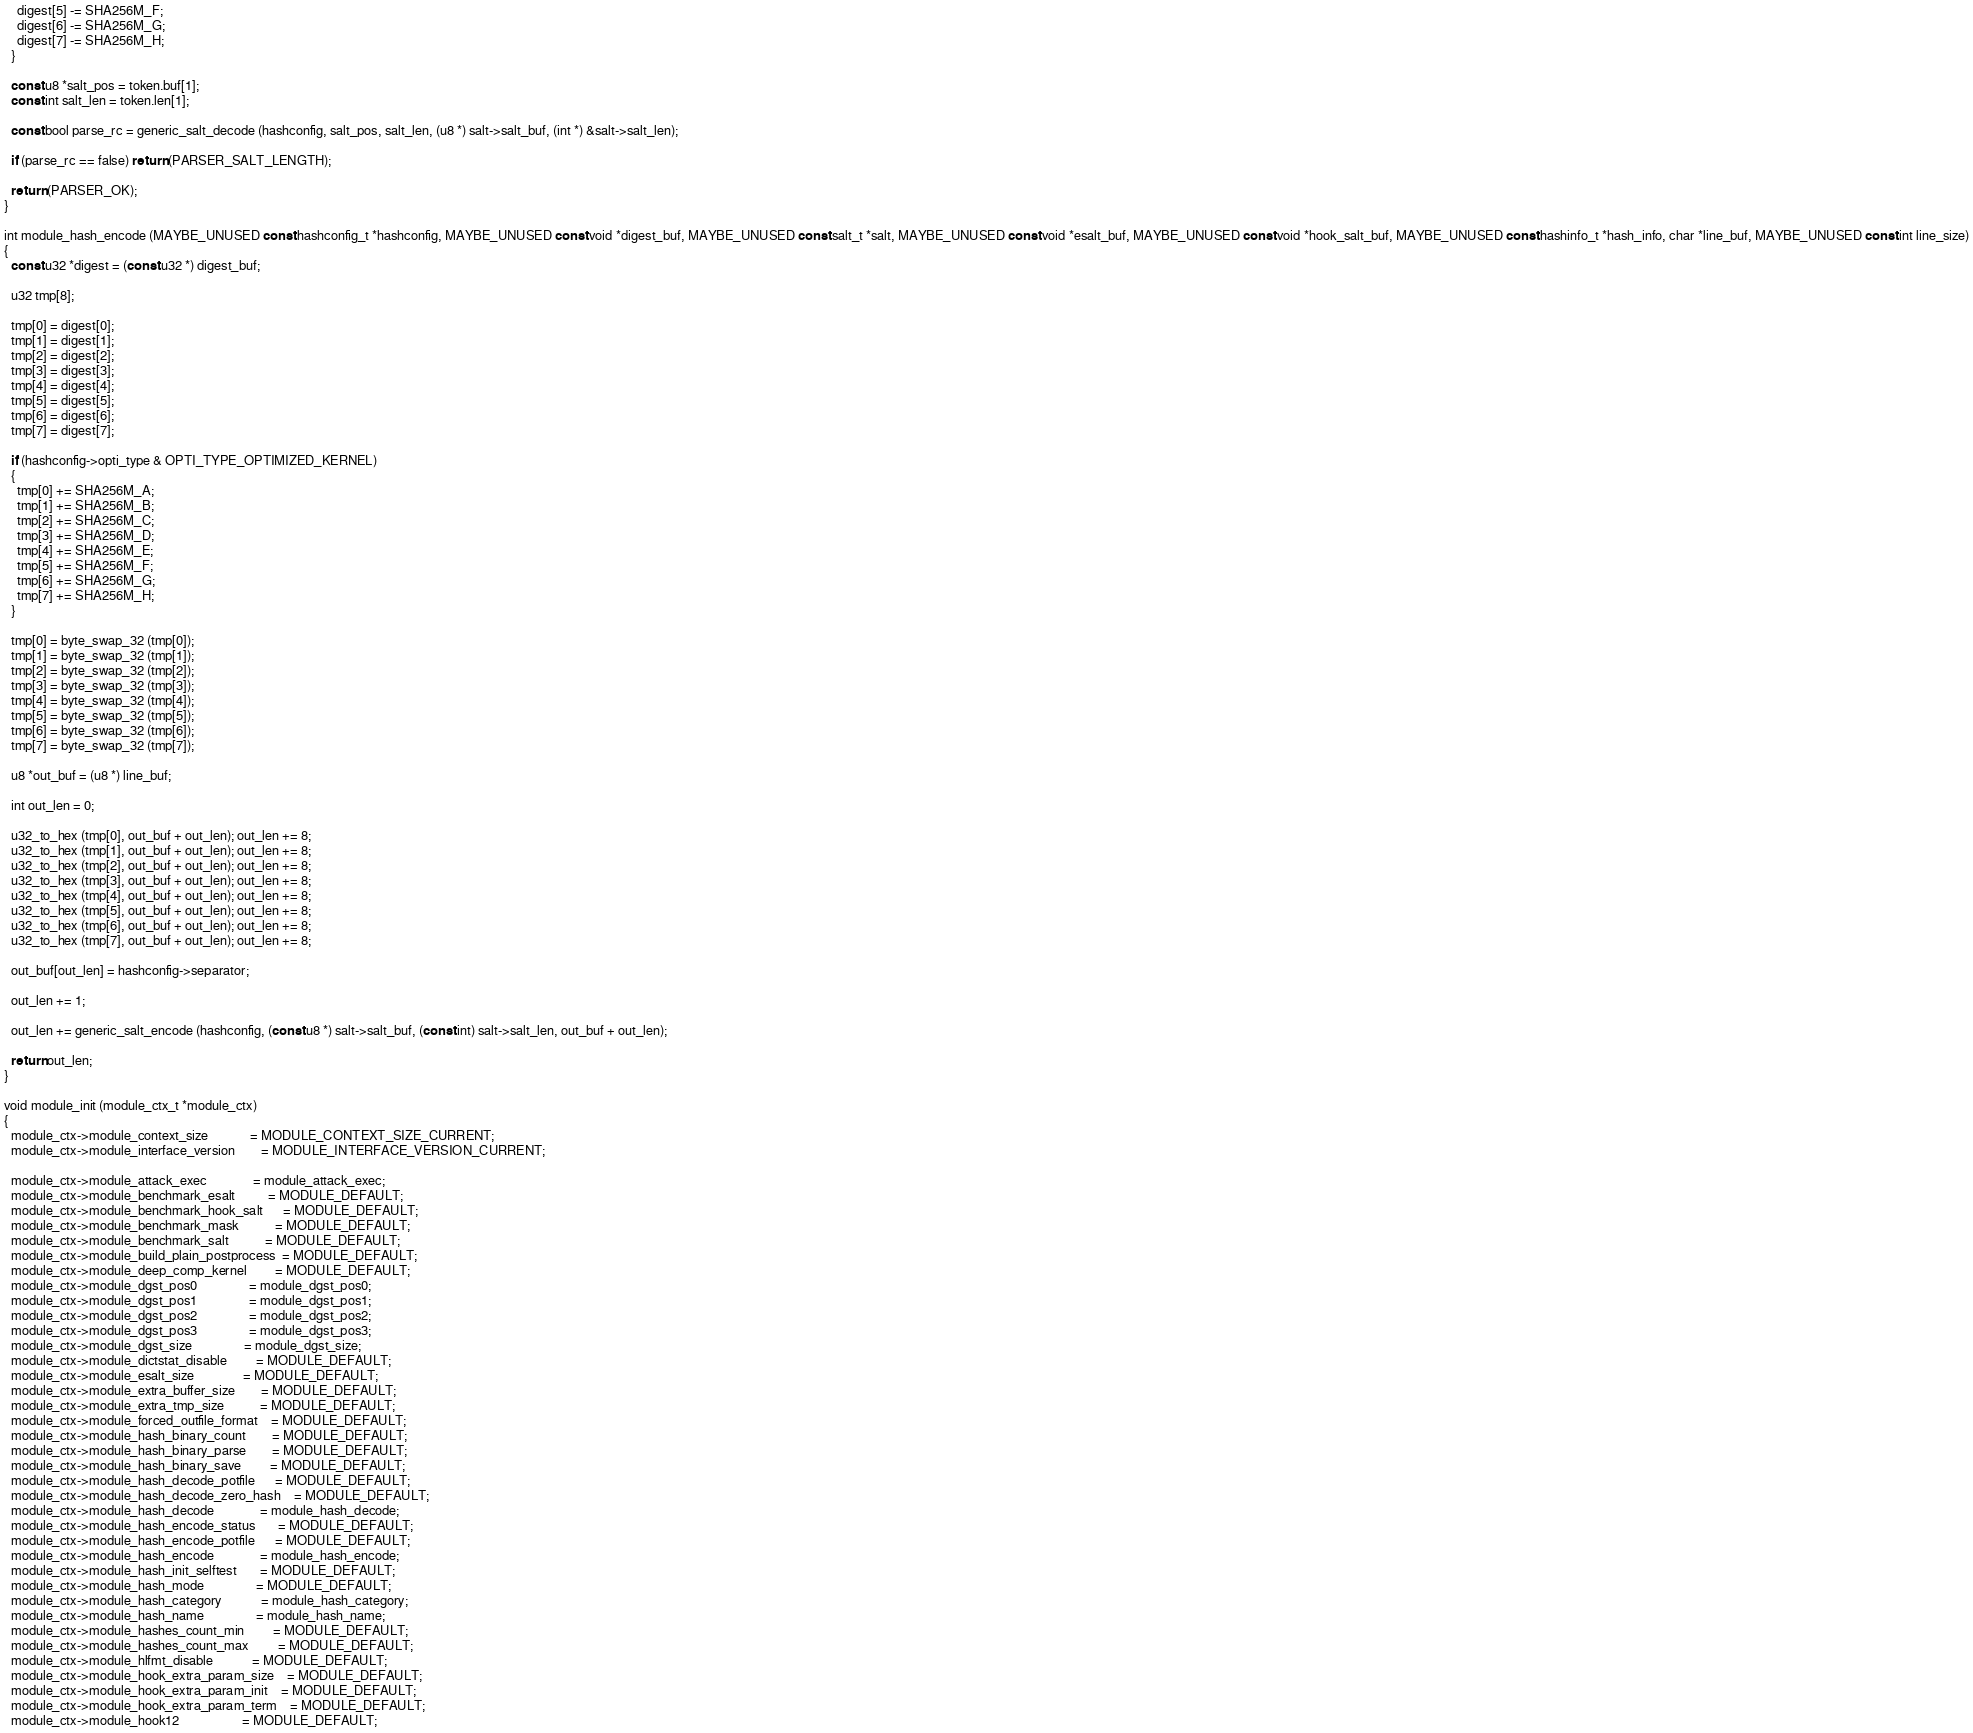Convert code to text. <code><loc_0><loc_0><loc_500><loc_500><_C_>    digest[5] -= SHA256M_F;
    digest[6] -= SHA256M_G;
    digest[7] -= SHA256M_H;
  }

  const u8 *salt_pos = token.buf[1];
  const int salt_len = token.len[1];

  const bool parse_rc = generic_salt_decode (hashconfig, salt_pos, salt_len, (u8 *) salt->salt_buf, (int *) &salt->salt_len);

  if (parse_rc == false) return (PARSER_SALT_LENGTH);

  return (PARSER_OK);
}

int module_hash_encode (MAYBE_UNUSED const hashconfig_t *hashconfig, MAYBE_UNUSED const void *digest_buf, MAYBE_UNUSED const salt_t *salt, MAYBE_UNUSED const void *esalt_buf, MAYBE_UNUSED const void *hook_salt_buf, MAYBE_UNUSED const hashinfo_t *hash_info, char *line_buf, MAYBE_UNUSED const int line_size)
{
  const u32 *digest = (const u32 *) digest_buf;

  u32 tmp[8];

  tmp[0] = digest[0];
  tmp[1] = digest[1];
  tmp[2] = digest[2];
  tmp[3] = digest[3];
  tmp[4] = digest[4];
  tmp[5] = digest[5];
  tmp[6] = digest[6];
  tmp[7] = digest[7];

  if (hashconfig->opti_type & OPTI_TYPE_OPTIMIZED_KERNEL)
  {
    tmp[0] += SHA256M_A;
    tmp[1] += SHA256M_B;
    tmp[2] += SHA256M_C;
    tmp[3] += SHA256M_D;
    tmp[4] += SHA256M_E;
    tmp[5] += SHA256M_F;
    tmp[6] += SHA256M_G;
    tmp[7] += SHA256M_H;
  }

  tmp[0] = byte_swap_32 (tmp[0]);
  tmp[1] = byte_swap_32 (tmp[1]);
  tmp[2] = byte_swap_32 (tmp[2]);
  tmp[3] = byte_swap_32 (tmp[3]);
  tmp[4] = byte_swap_32 (tmp[4]);
  tmp[5] = byte_swap_32 (tmp[5]);
  tmp[6] = byte_swap_32 (tmp[6]);
  tmp[7] = byte_swap_32 (tmp[7]);

  u8 *out_buf = (u8 *) line_buf;

  int out_len = 0;

  u32_to_hex (tmp[0], out_buf + out_len); out_len += 8;
  u32_to_hex (tmp[1], out_buf + out_len); out_len += 8;
  u32_to_hex (tmp[2], out_buf + out_len); out_len += 8;
  u32_to_hex (tmp[3], out_buf + out_len); out_len += 8;
  u32_to_hex (tmp[4], out_buf + out_len); out_len += 8;
  u32_to_hex (tmp[5], out_buf + out_len); out_len += 8;
  u32_to_hex (tmp[6], out_buf + out_len); out_len += 8;
  u32_to_hex (tmp[7], out_buf + out_len); out_len += 8;

  out_buf[out_len] = hashconfig->separator;

  out_len += 1;

  out_len += generic_salt_encode (hashconfig, (const u8 *) salt->salt_buf, (const int) salt->salt_len, out_buf + out_len);

  return out_len;
}

void module_init (module_ctx_t *module_ctx)
{
  module_ctx->module_context_size             = MODULE_CONTEXT_SIZE_CURRENT;
  module_ctx->module_interface_version        = MODULE_INTERFACE_VERSION_CURRENT;

  module_ctx->module_attack_exec              = module_attack_exec;
  module_ctx->module_benchmark_esalt          = MODULE_DEFAULT;
  module_ctx->module_benchmark_hook_salt      = MODULE_DEFAULT;
  module_ctx->module_benchmark_mask           = MODULE_DEFAULT;
  module_ctx->module_benchmark_salt           = MODULE_DEFAULT;
  module_ctx->module_build_plain_postprocess  = MODULE_DEFAULT;
  module_ctx->module_deep_comp_kernel         = MODULE_DEFAULT;
  module_ctx->module_dgst_pos0                = module_dgst_pos0;
  module_ctx->module_dgst_pos1                = module_dgst_pos1;
  module_ctx->module_dgst_pos2                = module_dgst_pos2;
  module_ctx->module_dgst_pos3                = module_dgst_pos3;
  module_ctx->module_dgst_size                = module_dgst_size;
  module_ctx->module_dictstat_disable         = MODULE_DEFAULT;
  module_ctx->module_esalt_size               = MODULE_DEFAULT;
  module_ctx->module_extra_buffer_size        = MODULE_DEFAULT;
  module_ctx->module_extra_tmp_size           = MODULE_DEFAULT;
  module_ctx->module_forced_outfile_format    = MODULE_DEFAULT;
  module_ctx->module_hash_binary_count        = MODULE_DEFAULT;
  module_ctx->module_hash_binary_parse        = MODULE_DEFAULT;
  module_ctx->module_hash_binary_save         = MODULE_DEFAULT;
  module_ctx->module_hash_decode_potfile      = MODULE_DEFAULT;
  module_ctx->module_hash_decode_zero_hash    = MODULE_DEFAULT;
  module_ctx->module_hash_decode              = module_hash_decode;
  module_ctx->module_hash_encode_status       = MODULE_DEFAULT;
  module_ctx->module_hash_encode_potfile      = MODULE_DEFAULT;
  module_ctx->module_hash_encode              = module_hash_encode;
  module_ctx->module_hash_init_selftest       = MODULE_DEFAULT;
  module_ctx->module_hash_mode                = MODULE_DEFAULT;
  module_ctx->module_hash_category            = module_hash_category;
  module_ctx->module_hash_name                = module_hash_name;
  module_ctx->module_hashes_count_min         = MODULE_DEFAULT;
  module_ctx->module_hashes_count_max         = MODULE_DEFAULT;
  module_ctx->module_hlfmt_disable            = MODULE_DEFAULT;
  module_ctx->module_hook_extra_param_size    = MODULE_DEFAULT;
  module_ctx->module_hook_extra_param_init    = MODULE_DEFAULT;
  module_ctx->module_hook_extra_param_term    = MODULE_DEFAULT;
  module_ctx->module_hook12                   = MODULE_DEFAULT;</code> 